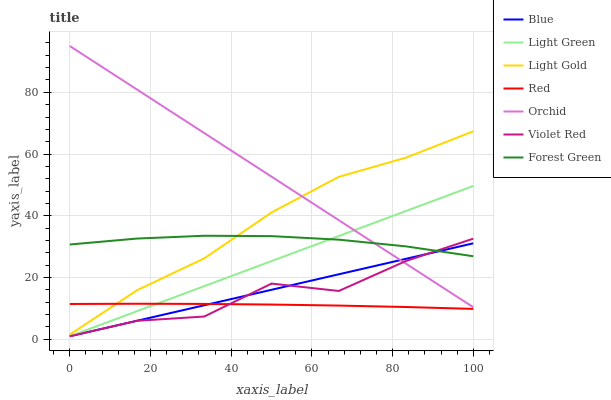Does Red have the minimum area under the curve?
Answer yes or no. Yes. Does Orchid have the maximum area under the curve?
Answer yes or no. Yes. Does Violet Red have the minimum area under the curve?
Answer yes or no. No. Does Violet Red have the maximum area under the curve?
Answer yes or no. No. Is Blue the smoothest?
Answer yes or no. Yes. Is Violet Red the roughest?
Answer yes or no. Yes. Is Forest Green the smoothest?
Answer yes or no. No. Is Forest Green the roughest?
Answer yes or no. No. Does Blue have the lowest value?
Answer yes or no. Yes. Does Forest Green have the lowest value?
Answer yes or no. No. Does Orchid have the highest value?
Answer yes or no. Yes. Does Violet Red have the highest value?
Answer yes or no. No. Is Red less than Forest Green?
Answer yes or no. Yes. Is Forest Green greater than Red?
Answer yes or no. Yes. Does Violet Red intersect Blue?
Answer yes or no. Yes. Is Violet Red less than Blue?
Answer yes or no. No. Is Violet Red greater than Blue?
Answer yes or no. No. Does Red intersect Forest Green?
Answer yes or no. No. 